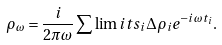Convert formula to latex. <formula><loc_0><loc_0><loc_500><loc_500>\rho _ { \omega } = \frac { i } { 2 \pi \omega } \sum \lim i t s _ { i } \Delta \rho _ { i } e ^ { - i \omega t _ { i } } .</formula> 